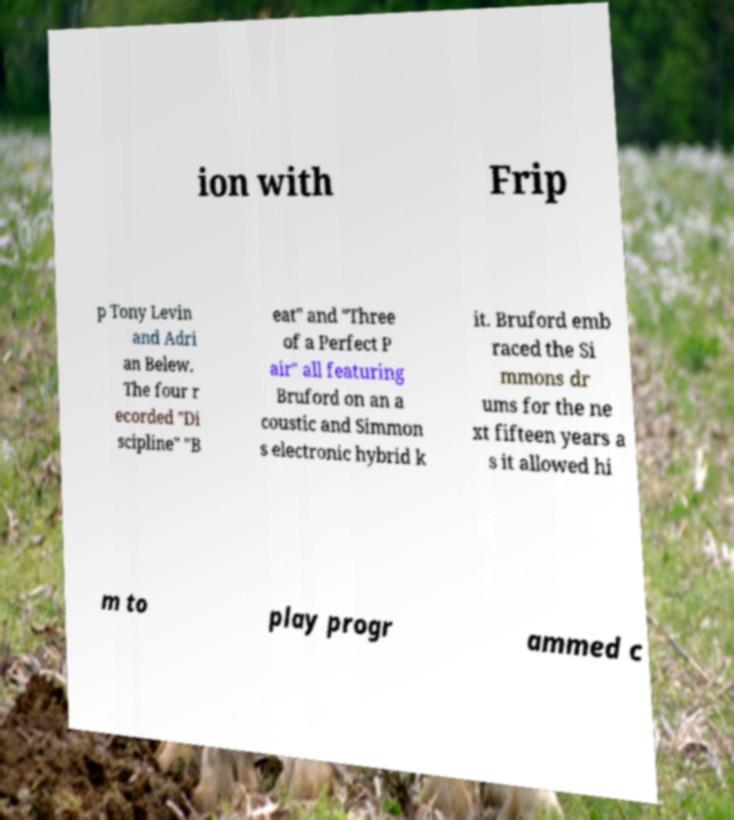For documentation purposes, I need the text within this image transcribed. Could you provide that? ion with Frip p Tony Levin and Adri an Belew. The four r ecorded "Di scipline" "B eat" and "Three of a Perfect P air" all featuring Bruford on an a coustic and Simmon s electronic hybrid k it. Bruford emb raced the Si mmons dr ums for the ne xt fifteen years a s it allowed hi m to play progr ammed c 